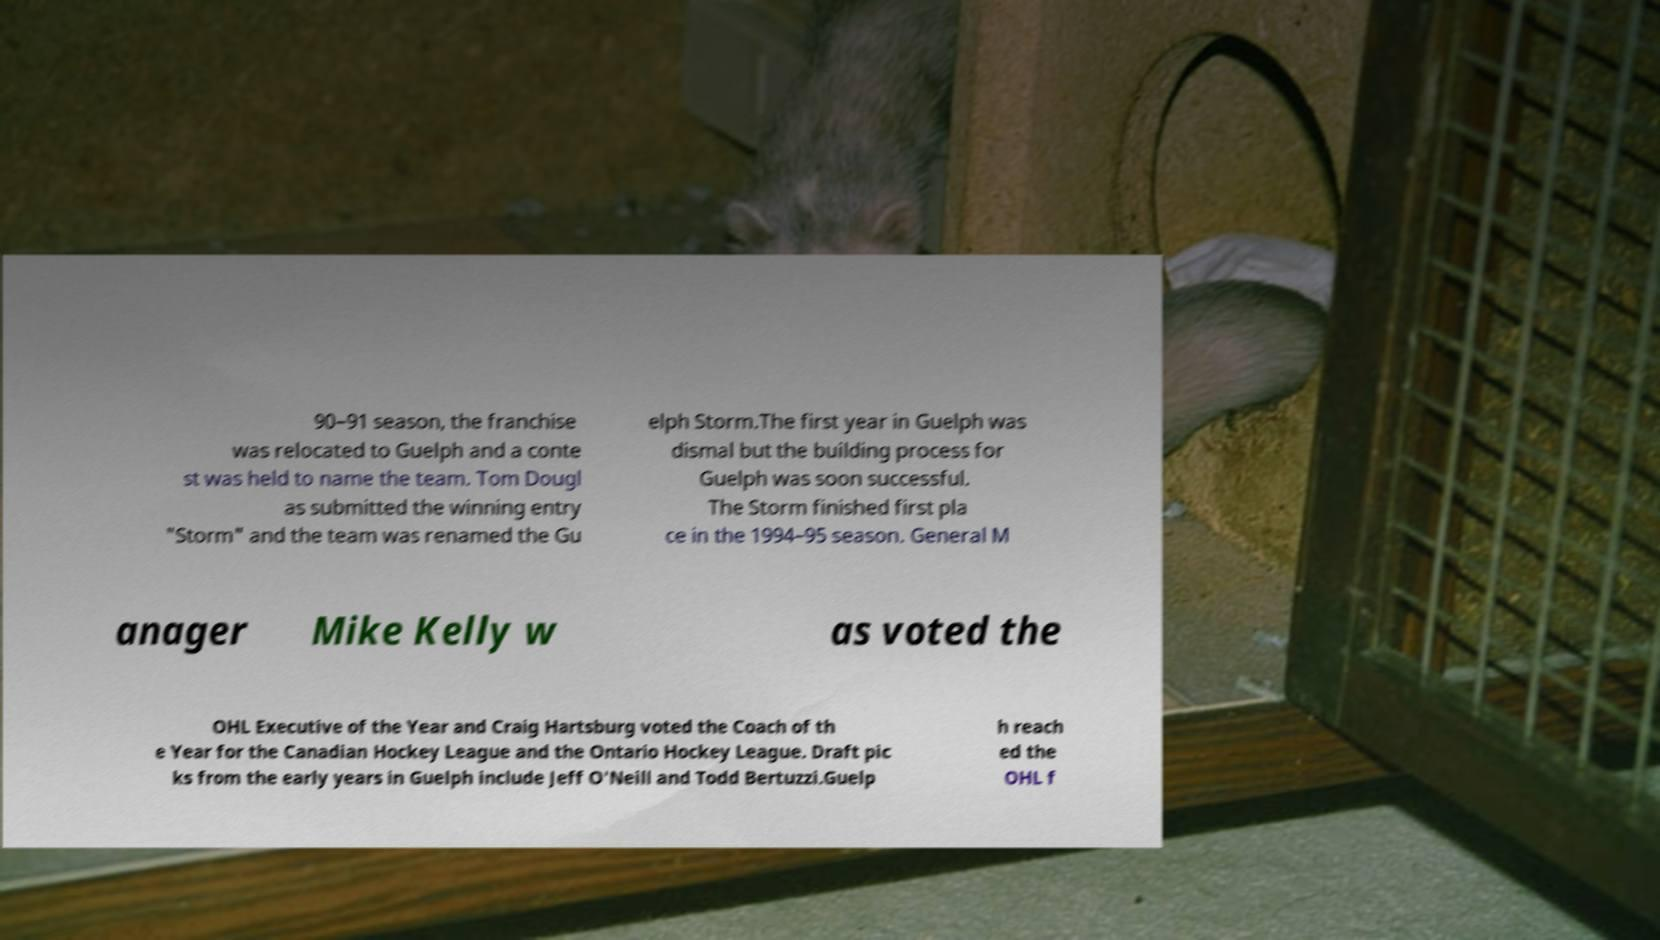Could you assist in decoding the text presented in this image and type it out clearly? 90–91 season, the franchise was relocated to Guelph and a conte st was held to name the team. Tom Dougl as submitted the winning entry "Storm" and the team was renamed the Gu elph Storm.The first year in Guelph was dismal but the building process for Guelph was soon successful. The Storm finished first pla ce in the 1994–95 season. General M anager Mike Kelly w as voted the OHL Executive of the Year and Craig Hartsburg voted the Coach of th e Year for the Canadian Hockey League and the Ontario Hockey League. Draft pic ks from the early years in Guelph include Jeff O'Neill and Todd Bertuzzi.Guelp h reach ed the OHL f 